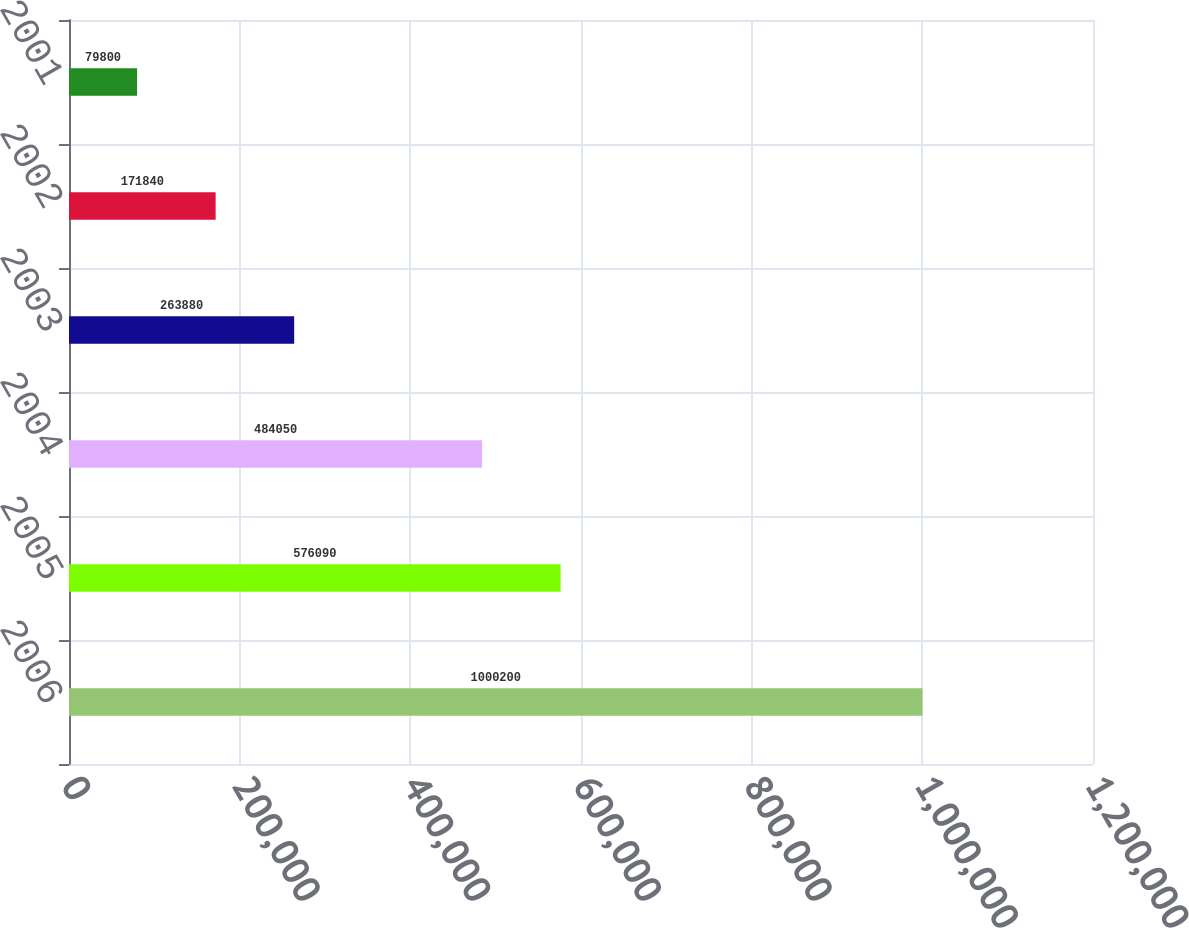<chart> <loc_0><loc_0><loc_500><loc_500><bar_chart><fcel>2006<fcel>2005<fcel>2004<fcel>2003<fcel>2002<fcel>2001<nl><fcel>1.0002e+06<fcel>576090<fcel>484050<fcel>263880<fcel>171840<fcel>79800<nl></chart> 